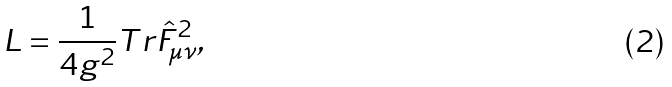<formula> <loc_0><loc_0><loc_500><loc_500>L = \frac { 1 } { 4 g ^ { 2 } } T r \hat { F } _ { \mu \nu } ^ { 2 } ,</formula> 